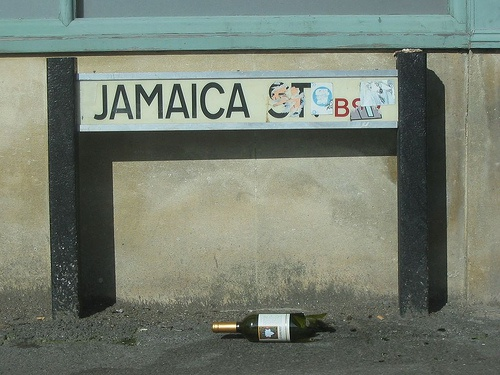Describe the objects in this image and their specific colors. I can see a bottle in gray, black, lightgray, and darkgray tones in this image. 